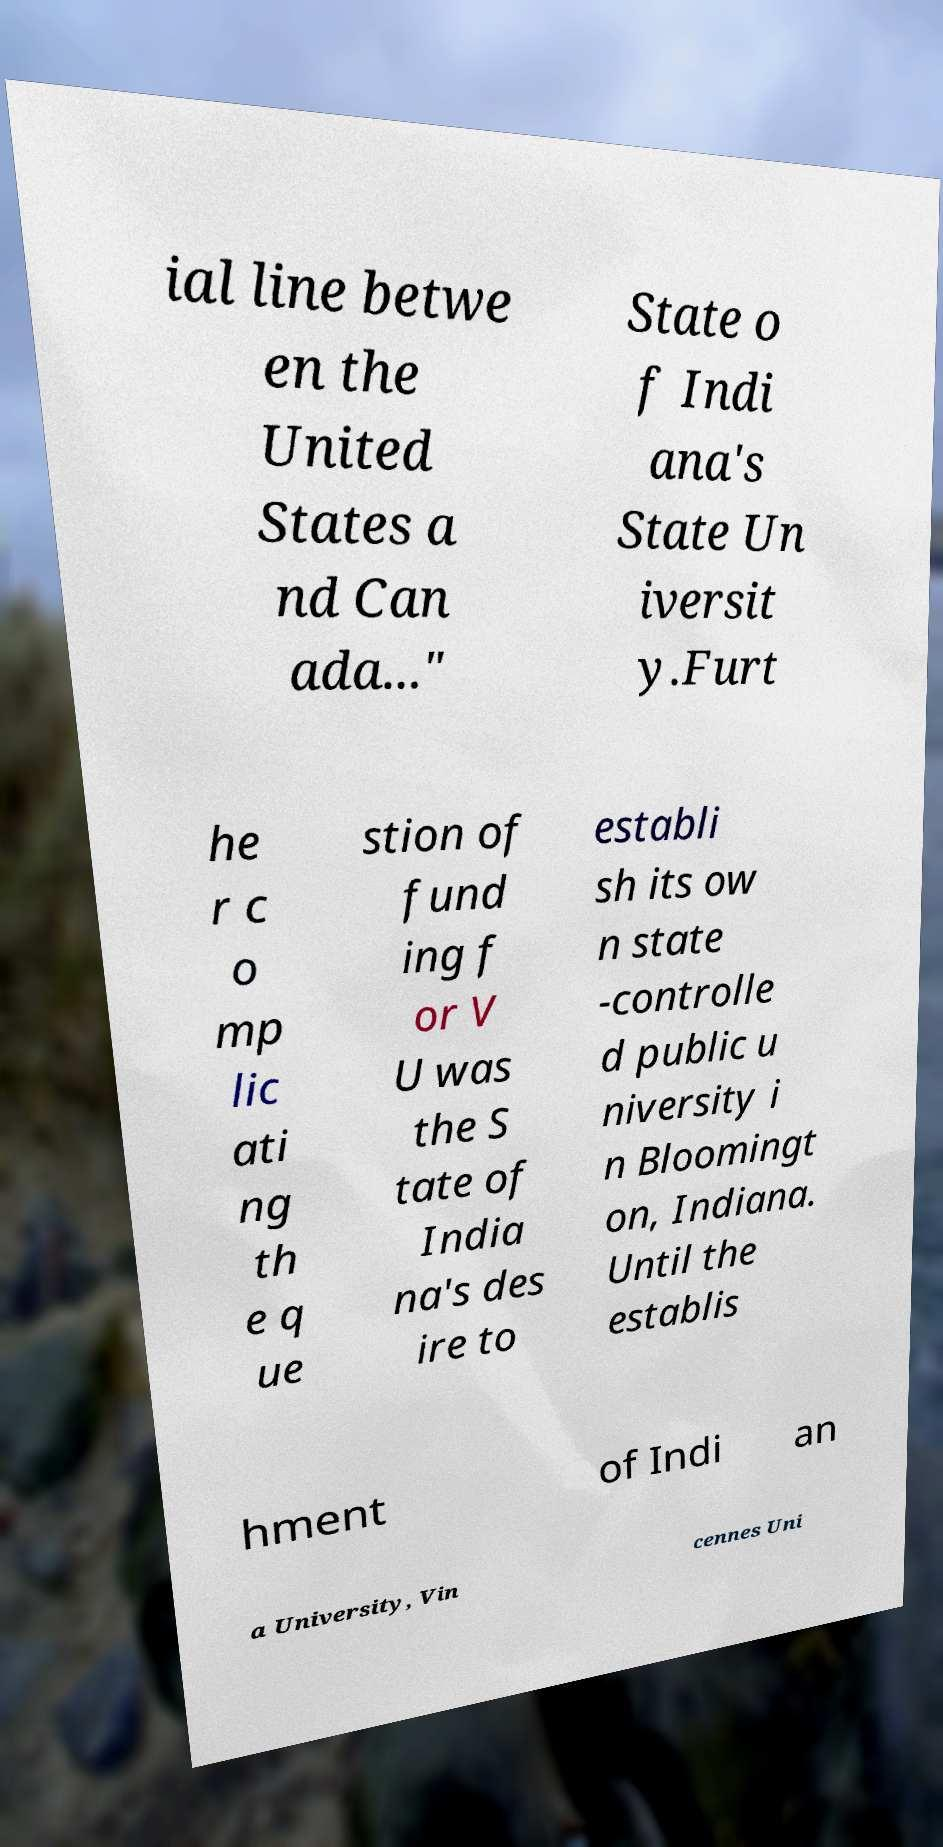Can you read and provide the text displayed in the image?This photo seems to have some interesting text. Can you extract and type it out for me? ial line betwe en the United States a nd Can ada..." State o f Indi ana's State Un iversit y.Furt he r c o mp lic ati ng th e q ue stion of fund ing f or V U was the S tate of India na's des ire to establi sh its ow n state -controlle d public u niversity i n Bloomingt on, Indiana. Until the establis hment of Indi an a University, Vin cennes Uni 